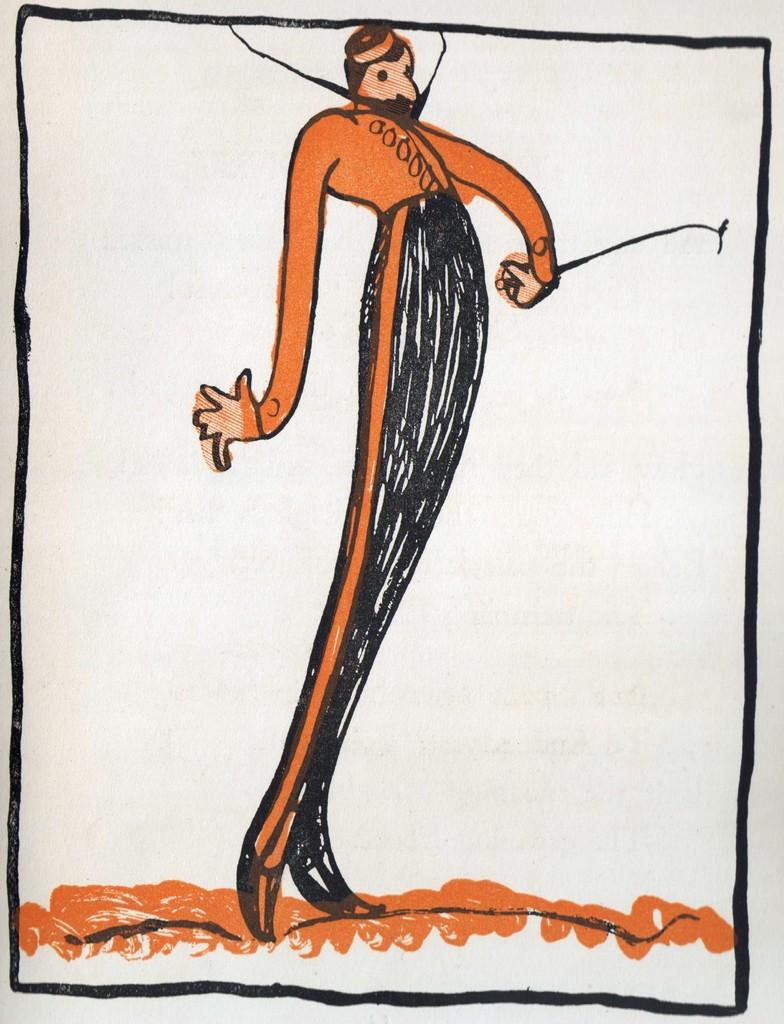What type of artwork is depicted in the image? The image is a painting. What colors are used in the painting? The painting is colored with orange and black. What type of plant is growing in the carriage in the image? There is no carriage or plant present in the image; it is a painting with orange and black colors. 